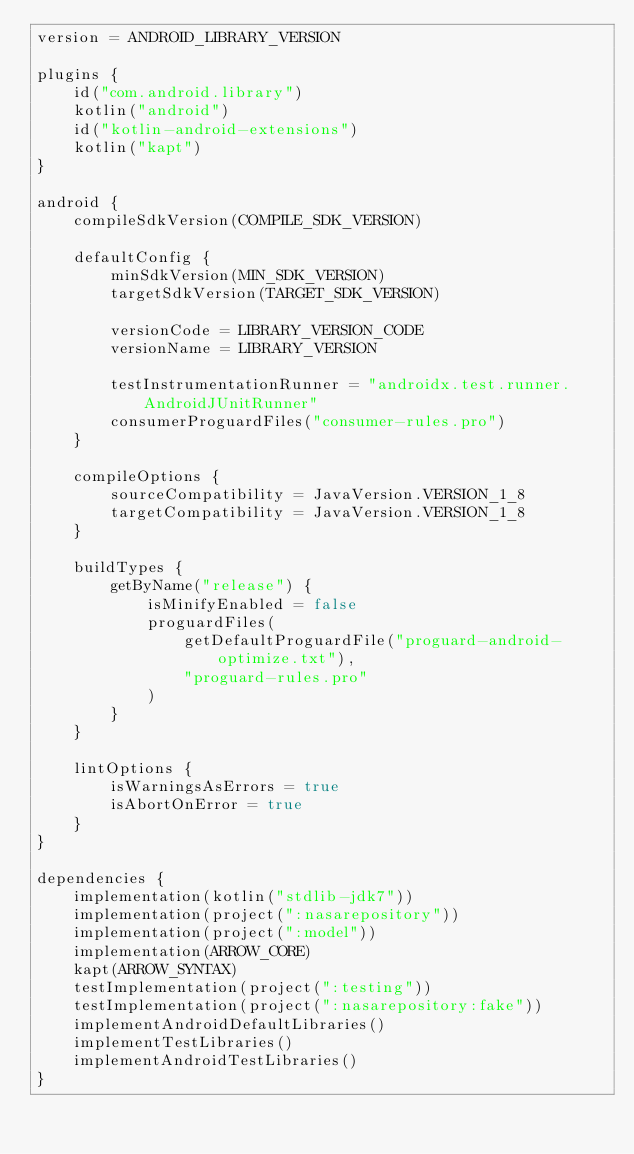Convert code to text. <code><loc_0><loc_0><loc_500><loc_500><_Kotlin_>version = ANDROID_LIBRARY_VERSION

plugins {
    id("com.android.library")
    kotlin("android")
    id("kotlin-android-extensions")
    kotlin("kapt")
}

android {
    compileSdkVersion(COMPILE_SDK_VERSION)

    defaultConfig {
        minSdkVersion(MIN_SDK_VERSION)
        targetSdkVersion(TARGET_SDK_VERSION)

        versionCode = LIBRARY_VERSION_CODE
        versionName = LIBRARY_VERSION

        testInstrumentationRunner = "androidx.test.runner.AndroidJUnitRunner"
        consumerProguardFiles("consumer-rules.pro")
    }

    compileOptions {
        sourceCompatibility = JavaVersion.VERSION_1_8
        targetCompatibility = JavaVersion.VERSION_1_8
    }

    buildTypes {
        getByName("release") {
            isMinifyEnabled = false
            proguardFiles(
                getDefaultProguardFile("proguard-android-optimize.txt"),
                "proguard-rules.pro"
            )
        }
    }

    lintOptions {
        isWarningsAsErrors = true
        isAbortOnError = true
    }
}

dependencies {
    implementation(kotlin("stdlib-jdk7"))
    implementation(project(":nasarepository"))
    implementation(project(":model"))
    implementation(ARROW_CORE)
    kapt(ARROW_SYNTAX)
    testImplementation(project(":testing"))
    testImplementation(project(":nasarepository:fake"))
    implementAndroidDefaultLibraries()
    implementTestLibraries()
    implementAndroidTestLibraries()
}
</code> 